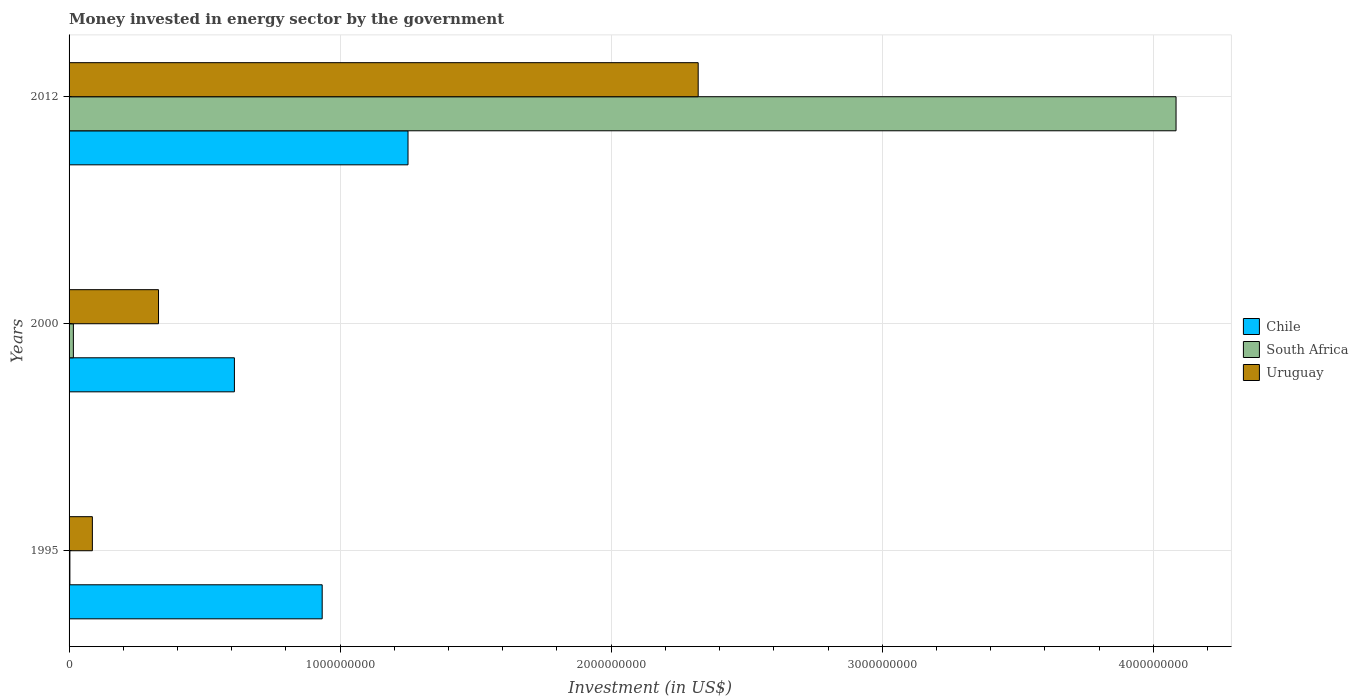How many groups of bars are there?
Provide a short and direct response. 3. How many bars are there on the 2nd tick from the top?
Offer a terse response. 3. What is the label of the 3rd group of bars from the top?
Your answer should be very brief. 1995. What is the money spent in energy sector in South Africa in 2012?
Your answer should be compact. 4.08e+09. Across all years, what is the maximum money spent in energy sector in Chile?
Give a very brief answer. 1.25e+09. Across all years, what is the minimum money spent in energy sector in Uruguay?
Provide a succinct answer. 8.60e+07. In which year was the money spent in energy sector in Uruguay maximum?
Keep it short and to the point. 2012. In which year was the money spent in energy sector in South Africa minimum?
Your answer should be very brief. 1995. What is the total money spent in energy sector in Uruguay in the graph?
Your response must be concise. 2.74e+09. What is the difference between the money spent in energy sector in Chile in 1995 and that in 2012?
Make the answer very short. -3.17e+08. What is the difference between the money spent in energy sector in Chile in 2000 and the money spent in energy sector in South Africa in 2012?
Offer a terse response. -3.47e+09. What is the average money spent in energy sector in Chile per year?
Give a very brief answer. 9.31e+08. In the year 1995, what is the difference between the money spent in energy sector in Chile and money spent in energy sector in South Africa?
Your answer should be compact. 9.31e+08. In how many years, is the money spent in energy sector in Chile greater than 1000000000 US$?
Make the answer very short. 1. What is the ratio of the money spent in energy sector in Uruguay in 1995 to that in 2012?
Make the answer very short. 0.04. Is the difference between the money spent in energy sector in Chile in 1995 and 2000 greater than the difference between the money spent in energy sector in South Africa in 1995 and 2000?
Provide a succinct answer. Yes. What is the difference between the highest and the second highest money spent in energy sector in Chile?
Offer a terse response. 3.17e+08. What is the difference between the highest and the lowest money spent in energy sector in Chile?
Your response must be concise. 6.40e+08. In how many years, is the money spent in energy sector in Chile greater than the average money spent in energy sector in Chile taken over all years?
Make the answer very short. 2. Is the sum of the money spent in energy sector in South Africa in 2000 and 2012 greater than the maximum money spent in energy sector in Uruguay across all years?
Make the answer very short. Yes. What does the 2nd bar from the top in 2000 represents?
Provide a short and direct response. South Africa. What does the 2nd bar from the bottom in 2012 represents?
Your response must be concise. South Africa. Is it the case that in every year, the sum of the money spent in energy sector in Chile and money spent in energy sector in Uruguay is greater than the money spent in energy sector in South Africa?
Provide a succinct answer. No. Are all the bars in the graph horizontal?
Offer a very short reply. Yes. How many years are there in the graph?
Provide a succinct answer. 3. Are the values on the major ticks of X-axis written in scientific E-notation?
Give a very brief answer. No. Does the graph contain grids?
Your answer should be compact. Yes. Where does the legend appear in the graph?
Your answer should be compact. Center right. How are the legend labels stacked?
Provide a succinct answer. Vertical. What is the title of the graph?
Your answer should be compact. Money invested in energy sector by the government. Does "Solomon Islands" appear as one of the legend labels in the graph?
Offer a terse response. No. What is the label or title of the X-axis?
Provide a short and direct response. Investment (in US$). What is the label or title of the Y-axis?
Ensure brevity in your answer.  Years. What is the Investment (in US$) of Chile in 1995?
Offer a very short reply. 9.34e+08. What is the Investment (in US$) of Uruguay in 1995?
Offer a very short reply. 8.60e+07. What is the Investment (in US$) of Chile in 2000?
Your response must be concise. 6.10e+08. What is the Investment (in US$) in South Africa in 2000?
Offer a very short reply. 1.59e+07. What is the Investment (in US$) in Uruguay in 2000?
Provide a short and direct response. 3.30e+08. What is the Investment (in US$) of Chile in 2012?
Give a very brief answer. 1.25e+09. What is the Investment (in US$) of South Africa in 2012?
Provide a short and direct response. 4.08e+09. What is the Investment (in US$) of Uruguay in 2012?
Provide a short and direct response. 2.32e+09. Across all years, what is the maximum Investment (in US$) in Chile?
Your response must be concise. 1.25e+09. Across all years, what is the maximum Investment (in US$) in South Africa?
Make the answer very short. 4.08e+09. Across all years, what is the maximum Investment (in US$) in Uruguay?
Provide a succinct answer. 2.32e+09. Across all years, what is the minimum Investment (in US$) of Chile?
Make the answer very short. 6.10e+08. Across all years, what is the minimum Investment (in US$) of South Africa?
Offer a very short reply. 3.00e+06. Across all years, what is the minimum Investment (in US$) of Uruguay?
Provide a short and direct response. 8.60e+07. What is the total Investment (in US$) in Chile in the graph?
Make the answer very short. 2.79e+09. What is the total Investment (in US$) in South Africa in the graph?
Offer a very short reply. 4.10e+09. What is the total Investment (in US$) of Uruguay in the graph?
Offer a very short reply. 2.74e+09. What is the difference between the Investment (in US$) of Chile in 1995 and that in 2000?
Your answer should be very brief. 3.24e+08. What is the difference between the Investment (in US$) of South Africa in 1995 and that in 2000?
Provide a succinct answer. -1.29e+07. What is the difference between the Investment (in US$) in Uruguay in 1995 and that in 2000?
Give a very brief answer. -2.44e+08. What is the difference between the Investment (in US$) of Chile in 1995 and that in 2012?
Your response must be concise. -3.17e+08. What is the difference between the Investment (in US$) of South Africa in 1995 and that in 2012?
Ensure brevity in your answer.  -4.08e+09. What is the difference between the Investment (in US$) of Uruguay in 1995 and that in 2012?
Provide a succinct answer. -2.24e+09. What is the difference between the Investment (in US$) of Chile in 2000 and that in 2012?
Provide a succinct answer. -6.40e+08. What is the difference between the Investment (in US$) of South Africa in 2000 and that in 2012?
Your response must be concise. -4.07e+09. What is the difference between the Investment (in US$) in Uruguay in 2000 and that in 2012?
Provide a short and direct response. -1.99e+09. What is the difference between the Investment (in US$) of Chile in 1995 and the Investment (in US$) of South Africa in 2000?
Your answer should be very brief. 9.18e+08. What is the difference between the Investment (in US$) of Chile in 1995 and the Investment (in US$) of Uruguay in 2000?
Your answer should be compact. 6.04e+08. What is the difference between the Investment (in US$) in South Africa in 1995 and the Investment (in US$) in Uruguay in 2000?
Provide a succinct answer. -3.27e+08. What is the difference between the Investment (in US$) of Chile in 1995 and the Investment (in US$) of South Africa in 2012?
Make the answer very short. -3.15e+09. What is the difference between the Investment (in US$) of Chile in 1995 and the Investment (in US$) of Uruguay in 2012?
Provide a short and direct response. -1.39e+09. What is the difference between the Investment (in US$) in South Africa in 1995 and the Investment (in US$) in Uruguay in 2012?
Give a very brief answer. -2.32e+09. What is the difference between the Investment (in US$) in Chile in 2000 and the Investment (in US$) in South Africa in 2012?
Offer a terse response. -3.47e+09. What is the difference between the Investment (in US$) of Chile in 2000 and the Investment (in US$) of Uruguay in 2012?
Your answer should be compact. -1.71e+09. What is the difference between the Investment (in US$) of South Africa in 2000 and the Investment (in US$) of Uruguay in 2012?
Your answer should be compact. -2.31e+09. What is the average Investment (in US$) of Chile per year?
Make the answer very short. 9.31e+08. What is the average Investment (in US$) in South Africa per year?
Provide a short and direct response. 1.37e+09. What is the average Investment (in US$) in Uruguay per year?
Provide a short and direct response. 9.12e+08. In the year 1995, what is the difference between the Investment (in US$) of Chile and Investment (in US$) of South Africa?
Offer a very short reply. 9.31e+08. In the year 1995, what is the difference between the Investment (in US$) of Chile and Investment (in US$) of Uruguay?
Provide a succinct answer. 8.48e+08. In the year 1995, what is the difference between the Investment (in US$) of South Africa and Investment (in US$) of Uruguay?
Provide a short and direct response. -8.30e+07. In the year 2000, what is the difference between the Investment (in US$) in Chile and Investment (in US$) in South Africa?
Provide a succinct answer. 5.94e+08. In the year 2000, what is the difference between the Investment (in US$) in Chile and Investment (in US$) in Uruguay?
Ensure brevity in your answer.  2.80e+08. In the year 2000, what is the difference between the Investment (in US$) in South Africa and Investment (in US$) in Uruguay?
Give a very brief answer. -3.14e+08. In the year 2012, what is the difference between the Investment (in US$) of Chile and Investment (in US$) of South Africa?
Keep it short and to the point. -2.83e+09. In the year 2012, what is the difference between the Investment (in US$) in Chile and Investment (in US$) in Uruguay?
Offer a very short reply. -1.07e+09. In the year 2012, what is the difference between the Investment (in US$) of South Africa and Investment (in US$) of Uruguay?
Ensure brevity in your answer.  1.76e+09. What is the ratio of the Investment (in US$) in Chile in 1995 to that in 2000?
Offer a very short reply. 1.53. What is the ratio of the Investment (in US$) of South Africa in 1995 to that in 2000?
Your answer should be compact. 0.19. What is the ratio of the Investment (in US$) of Uruguay in 1995 to that in 2000?
Ensure brevity in your answer.  0.26. What is the ratio of the Investment (in US$) in Chile in 1995 to that in 2012?
Offer a terse response. 0.75. What is the ratio of the Investment (in US$) of South Africa in 1995 to that in 2012?
Ensure brevity in your answer.  0. What is the ratio of the Investment (in US$) in Uruguay in 1995 to that in 2012?
Make the answer very short. 0.04. What is the ratio of the Investment (in US$) in Chile in 2000 to that in 2012?
Make the answer very short. 0.49. What is the ratio of the Investment (in US$) in South Africa in 2000 to that in 2012?
Your answer should be compact. 0. What is the ratio of the Investment (in US$) of Uruguay in 2000 to that in 2012?
Provide a succinct answer. 0.14. What is the difference between the highest and the second highest Investment (in US$) of Chile?
Offer a terse response. 3.17e+08. What is the difference between the highest and the second highest Investment (in US$) in South Africa?
Your answer should be compact. 4.07e+09. What is the difference between the highest and the second highest Investment (in US$) in Uruguay?
Make the answer very short. 1.99e+09. What is the difference between the highest and the lowest Investment (in US$) of Chile?
Provide a succinct answer. 6.40e+08. What is the difference between the highest and the lowest Investment (in US$) in South Africa?
Offer a very short reply. 4.08e+09. What is the difference between the highest and the lowest Investment (in US$) of Uruguay?
Provide a succinct answer. 2.24e+09. 